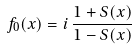<formula> <loc_0><loc_0><loc_500><loc_500>f _ { 0 } ( x ) = i \, \frac { 1 + S ( x ) } { 1 - S ( x ) }</formula> 